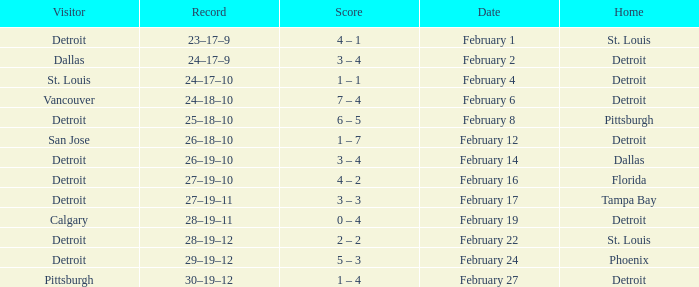Could you help me parse every detail presented in this table? {'header': ['Visitor', 'Record', 'Score', 'Date', 'Home'], 'rows': [['Detroit', '23–17–9', '4 – 1', 'February 1', 'St. Louis'], ['Dallas', '24–17–9', '3 – 4', 'February 2', 'Detroit'], ['St. Louis', '24–17–10', '1 – 1', 'February 4', 'Detroit'], ['Vancouver', '24–18–10', '7 – 4', 'February 6', 'Detroit'], ['Detroit', '25–18–10', '6 – 5', 'February 8', 'Pittsburgh'], ['San Jose', '26–18–10', '1 – 7', 'February 12', 'Detroit'], ['Detroit', '26–19–10', '3 – 4', 'February 14', 'Dallas'], ['Detroit', '27–19–10', '4 – 2', 'February 16', 'Florida'], ['Detroit', '27–19–11', '3 – 3', 'February 17', 'Tampa Bay'], ['Calgary', '28–19–11', '0 – 4', 'February 19', 'Detroit'], ['Detroit', '28–19–12', '2 – 2', 'February 22', 'St. Louis'], ['Detroit', '29–19–12', '5 – 3', 'February 24', 'Phoenix'], ['Pittsburgh', '30–19–12', '1 – 4', 'February 27', 'Detroit']]} What was their record when they were at Pittsburgh? 25–18–10. 